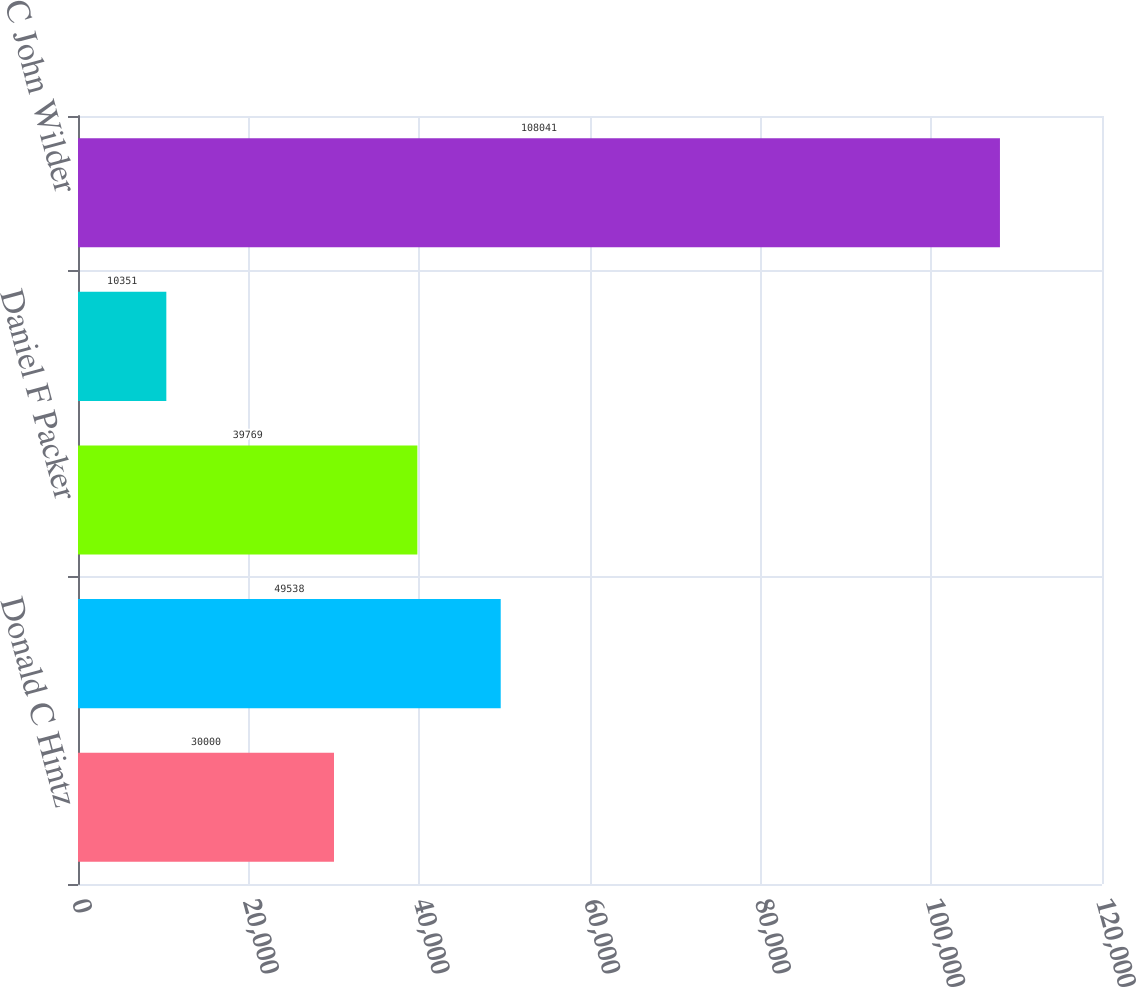Convert chart. <chart><loc_0><loc_0><loc_500><loc_500><bar_chart><fcel>Donald C Hintz<fcel>Jerry D Jackson<fcel>Daniel F Packer<fcel>Carolyn C Shanks<fcel>C John Wilder<nl><fcel>30000<fcel>49538<fcel>39769<fcel>10351<fcel>108041<nl></chart> 